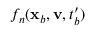Convert formula to latex. <formula><loc_0><loc_0><loc_500><loc_500>f _ { n } ( x _ { b } , v , t _ { b } ^ { \prime } )</formula> 